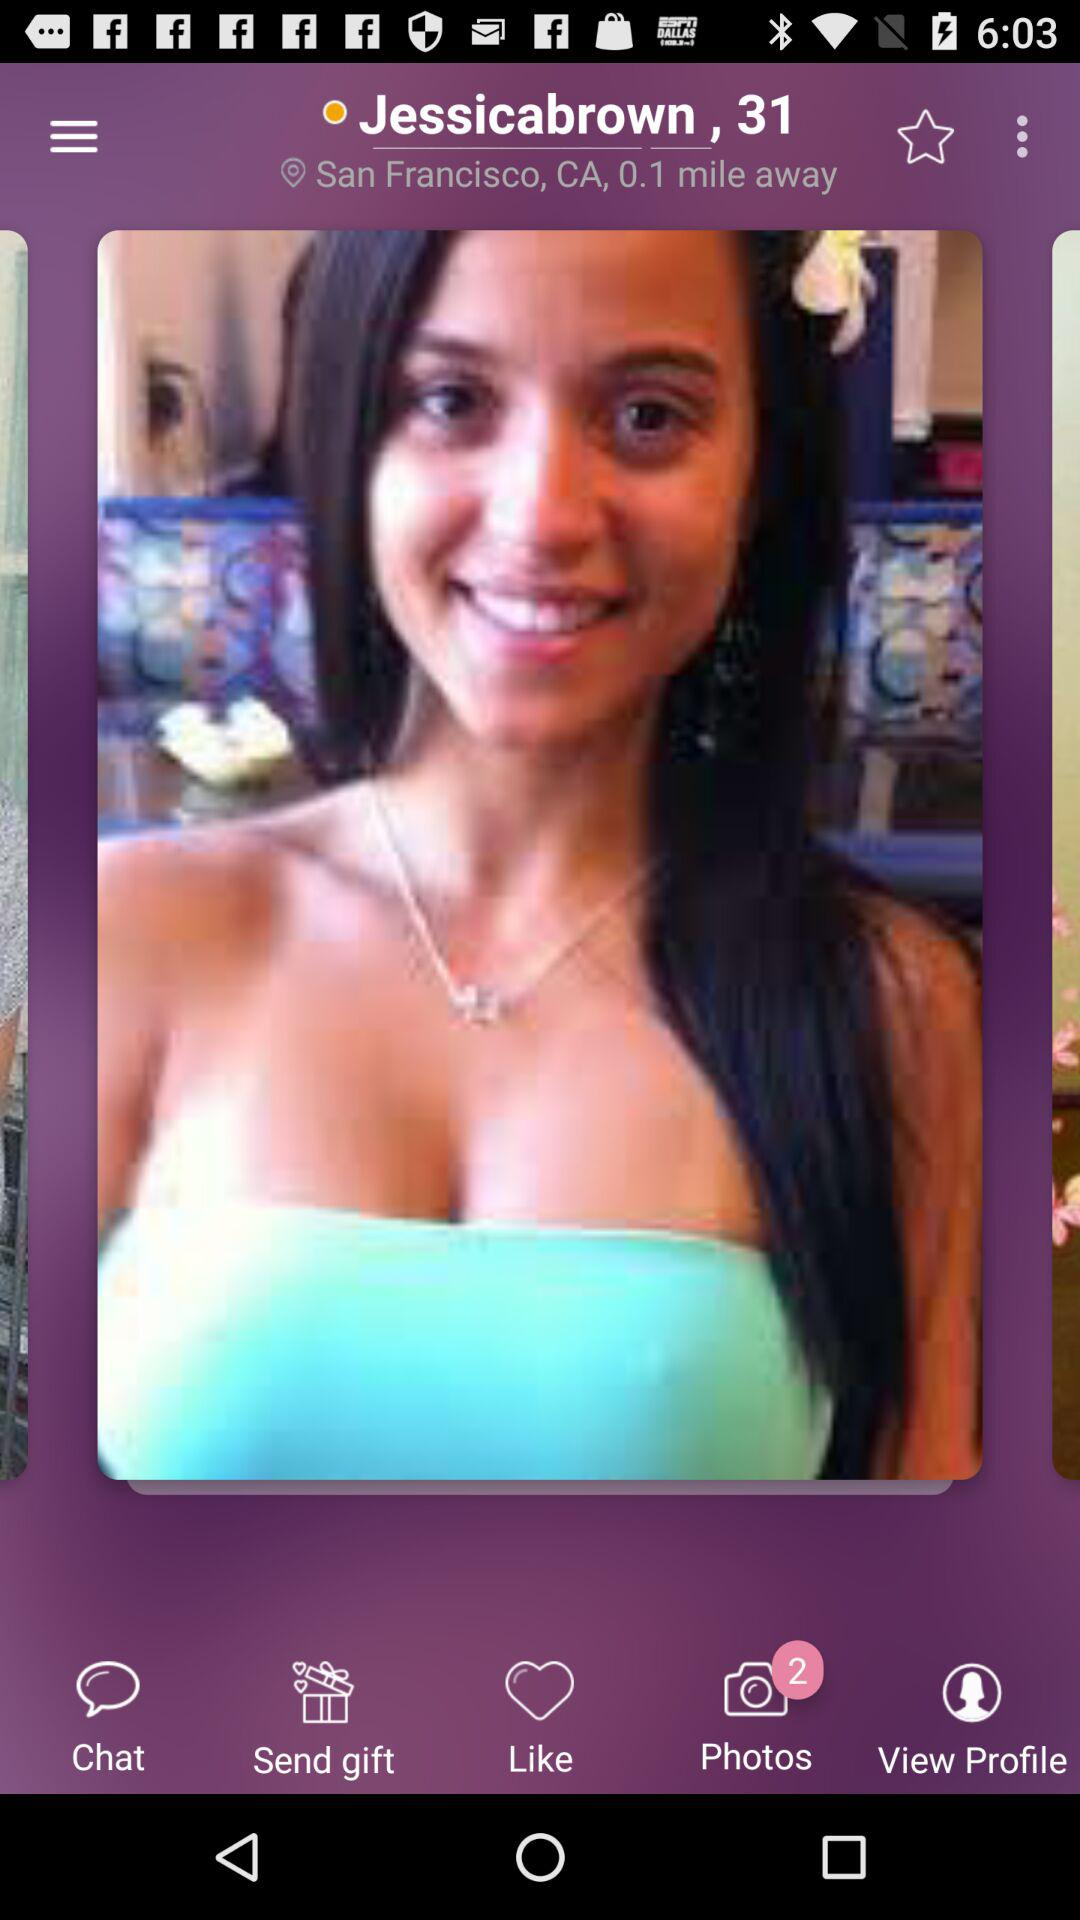What is the distance between "Jessicabrown" and my location? The distance is 0.1 mile. 